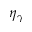<formula> <loc_0><loc_0><loc_500><loc_500>\eta _ { \gamma }</formula> 